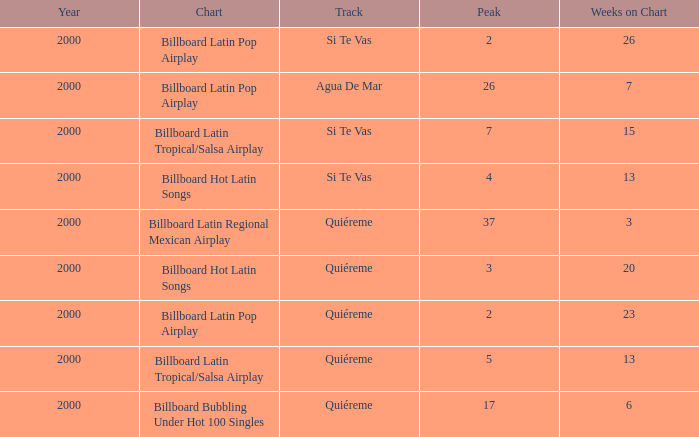Name the least weeks for year less than 2000 None. 